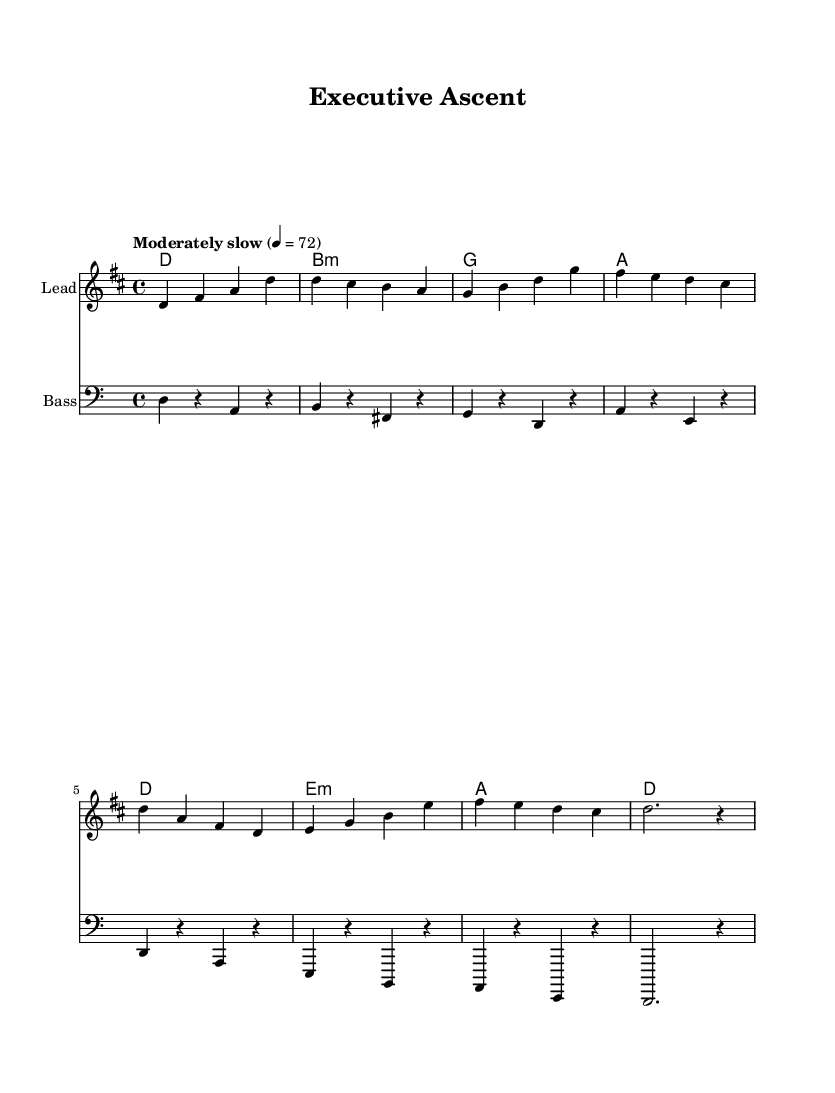What is the key signature of this music? The key signature is D major, which has two sharps (F# and C#).
Answer: D major What is the time signature of this music? The time signature is 4/4, which means there are four beats per measure and the quarter note gets one beat.
Answer: 4/4 What is the tempo marking of the music? The tempo marking indicates to play moderately slow at a speed of 72 beats per minute.
Answer: Moderately slow 72 How many measures are in the music? There are eight measures in the score, which can be counted by looking at the bar lines that separate each measure in the melody.
Answer: Eight What chord follows the D major chord in the progression? The progression shows the D major chord followed by B minor in the second measure, as indicated in the chord section.
Answer: B minor Which instrument is designated for the melody? The melody is assigned to the staff labeled "Lead," which indicates it is for the main instrument carrying the melody.
Answer: Lead What is the last note of the melody? The last note of the melody is a whole note, which is D, as indicated in the final measure of the melody staff.
Answer: D 